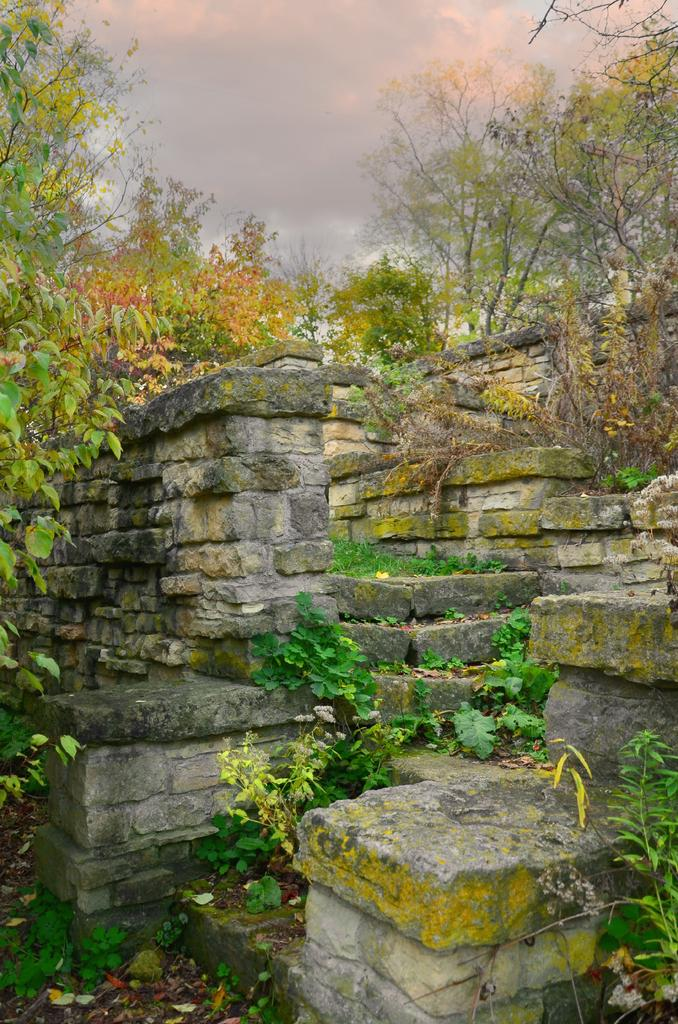What is present in the image that serves as a barrier or divider? There is a wall in the image. What type of living organisms can be seen in the image? Plants are present in the image. What can be seen in the background of the image? There are trees and clouds in the sky in the background of the image. What type of gold thread is being used to connect the trees in the image? There is no gold thread or connection between the trees in the image; they are separate entities in the background. 